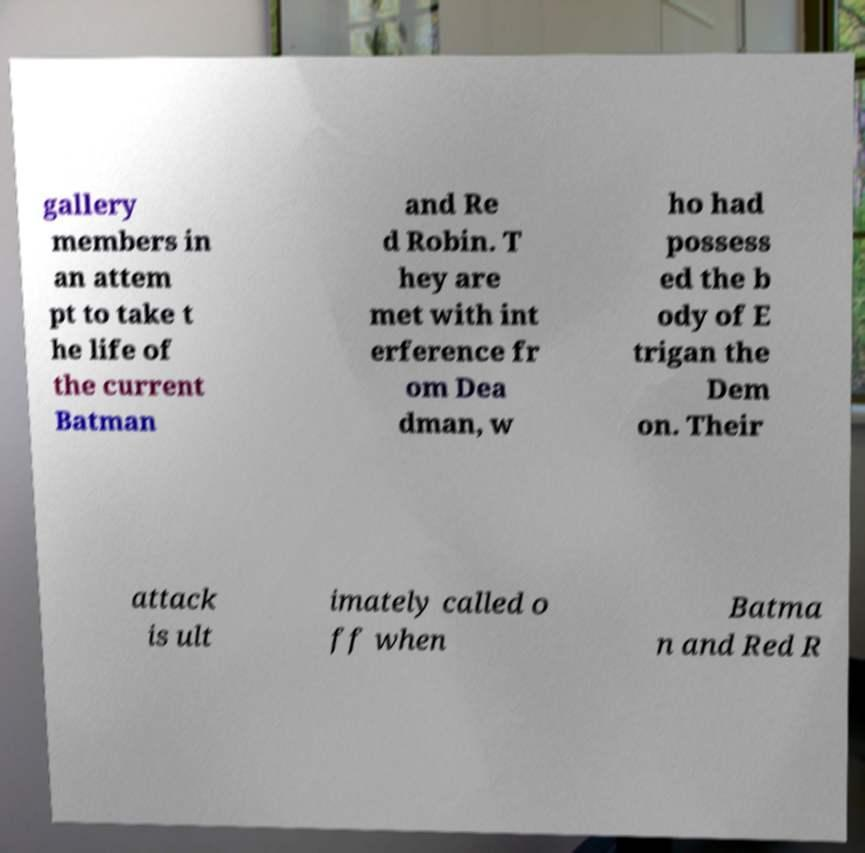Can you read and provide the text displayed in the image?This photo seems to have some interesting text. Can you extract and type it out for me? gallery members in an attem pt to take t he life of the current Batman and Re d Robin. T hey are met with int erference fr om Dea dman, w ho had possess ed the b ody of E trigan the Dem on. Their attack is ult imately called o ff when Batma n and Red R 